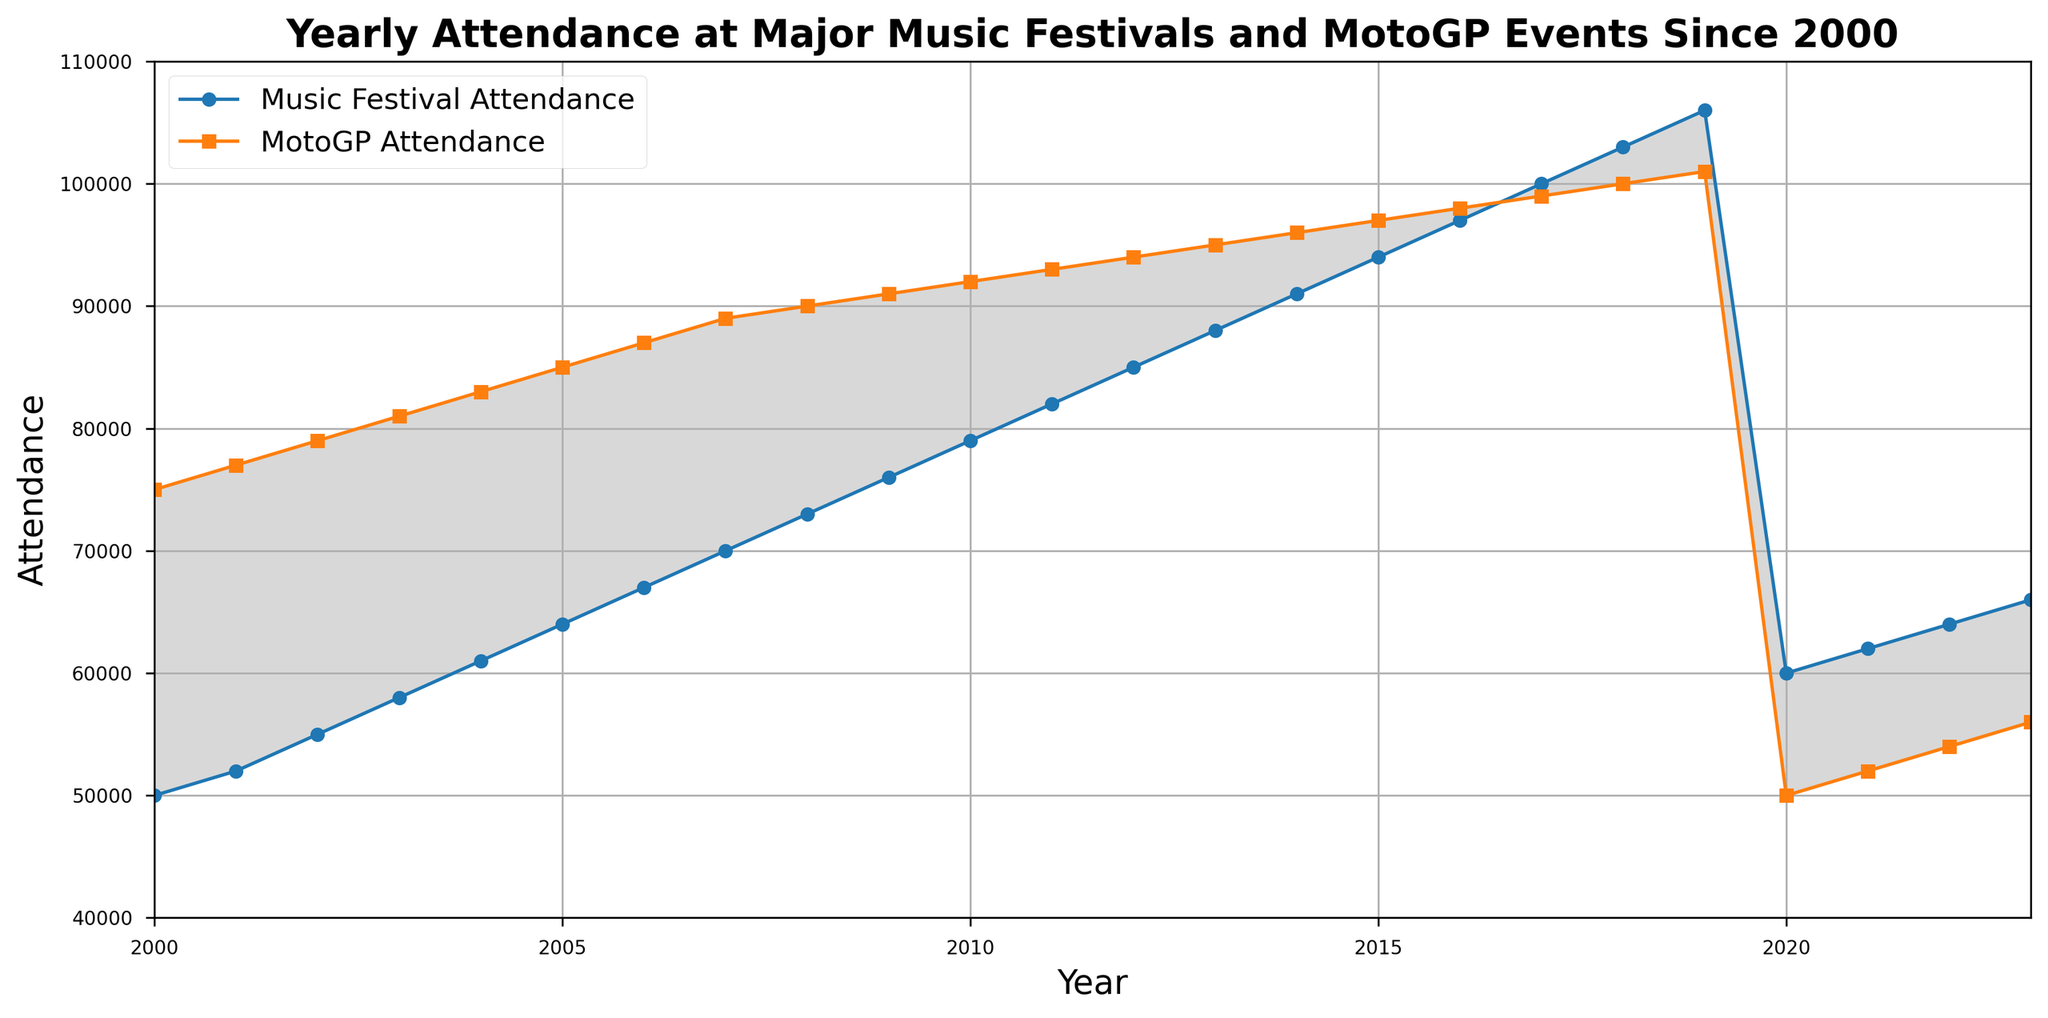Which year saw the highest attendance at MotoGP events? From the graph, the highest point of the MotoGP attendance line is at the year 2019 corresponding to 101,000 attendees.
Answer: 2019 How much did Music Festival attendance increase from 2000 to 2019? In 2000, Music Festival attendance was 50,000. In 2019, it was 106,000. The increase is calculated as 106,000 - 50,000 = 56,000.
Answer: 56,000 Which type of event had higher attendance in 2020, and by how much? In 2020, MotoGP attendance was 50,000, while Music Festival attendance was 60,000. The difference is 60,000 - 50,000 = 10,000 more for Music Festivals.
Answer: Music Festivals by 10,000 What is the average annual attendance for MotoGP events from 2018 to 2023? The MotoGP attendance from 2018 to 2023 is 100,000, 101,000, 50,000, 52,000, 54,000, 56,000. The average is calculated as (100,000 + 101,000 + 50,000 + 52,000 + 54,000 + 56,000) / 6 = 68,833.33.
Answer: 68,833.33 When did Music Festival attendance surpass MotoGP attendance, and by approximately how much? Music Festival attendance surpassed MotoGP attendance in 2020. In 2020, Music Festival attendance was 60,000, and MotoGP attendance was 50,000. The difference is 60,000 - 50,000 = 10,000.
Answer: 2020, by 10,000 What is the difference between the highest and lowest MotoGP attendance recorded? The highest MotoGP attendance is 101,000 in 2019, and the lowest is 50,000 in 2020. The difference is 101,000 - 50,000 = 51,000.
Answer: 51,000 How did the gap between Music Festival attendance and MotoGP attendance change from 2000 to 2019? In 2000, the gap was 75,000 - 50,000 = 25,000 in favor of MotoGP. By 2019, the gap was 106,000 - 101,000 = 5,000 in favor of Music Festivals, reducing the gap by 20,000.
Answer: Reduced by 20,000 Which years show a noticeable drop in both Music Festival and MotoGP attendance, and how much did they drop respectively? Both Music Festival and MotoGP attendance dropped significantly in 2020. Music Festival attendance dropped from 106,000 in 2019 to 60,000 in 2020, a drop of 46,000. MotoGP attendance dropped from 101,000 in 2019 to 50,000 in 2020, a drop of 51,000.
Answer: 2020, Music Festival by 46,000, MotoGP by 51,000 During which years did Music Festivals consistently grow in attendance, and by how much each year on average over that period? From 2000 to 2019, Music Festival attendance consistently grew each year. Total growth is 106,000 - 50,000 = 56,000 over 19 years. The average annual growth is 56,000 / 19 ≈ 2,947.37.
Answer: 2000 to 2019, by approximately 2,947.37 per year 